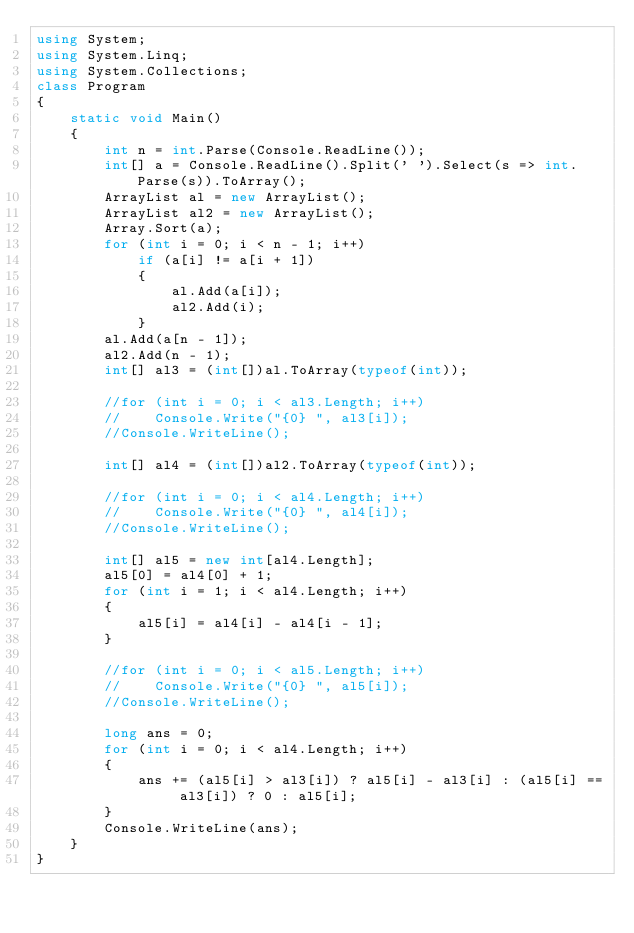<code> <loc_0><loc_0><loc_500><loc_500><_C#_>using System;
using System.Linq;
using System.Collections;
class Program
{
    static void Main()
    {
        int n = int.Parse(Console.ReadLine());
        int[] a = Console.ReadLine().Split(' ').Select(s => int.Parse(s)).ToArray();
        ArrayList al = new ArrayList();
        ArrayList al2 = new ArrayList();
        Array.Sort(a);
        for (int i = 0; i < n - 1; i++)
            if (a[i] != a[i + 1])
            {
                al.Add(a[i]);
                al2.Add(i);
            }
        al.Add(a[n - 1]);
        al2.Add(n - 1);
        int[] al3 = (int[])al.ToArray(typeof(int));

        //for (int i = 0; i < al3.Length; i++)
        //    Console.Write("{0} ", al3[i]);
        //Console.WriteLine();

        int[] al4 = (int[])al2.ToArray(typeof(int));

        //for (int i = 0; i < al4.Length; i++)
        //    Console.Write("{0} ", al4[i]);
        //Console.WriteLine();

        int[] al5 = new int[al4.Length];
        al5[0] = al4[0] + 1;
        for (int i = 1; i < al4.Length; i++)
        {
            al5[i] = al4[i] - al4[i - 1];
        }

        //for (int i = 0; i < al5.Length; i++)
        //    Console.Write("{0} ", al5[i]);
        //Console.WriteLine();

        long ans = 0;
        for (int i = 0; i < al4.Length; i++)
        {
            ans += (al5[i] > al3[i]) ? al5[i] - al3[i] : (al5[i] == al3[i]) ? 0 : al5[i];
        }
        Console.WriteLine(ans);
    }
}</code> 